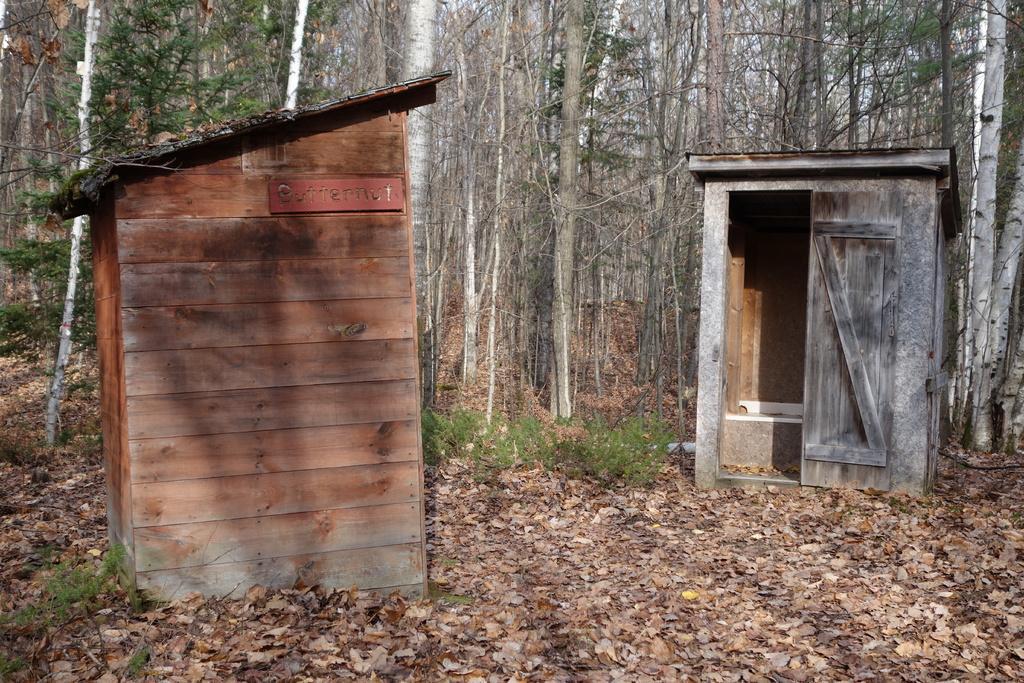How would you summarize this image in a sentence or two? In this image we can see wooden sheds, shredded leaves on the ground, shrubs, trees and sky. 